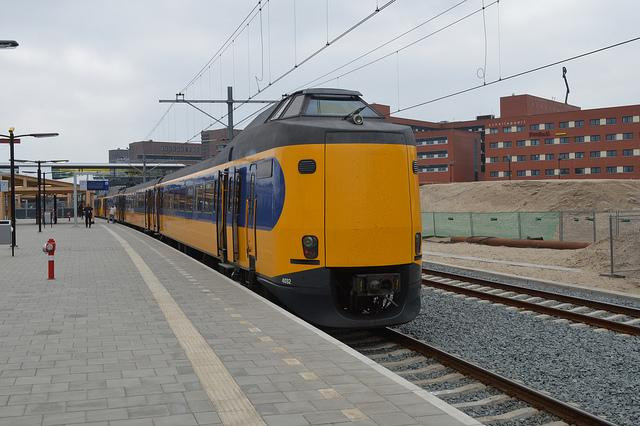What substance can be obtained from the red object? Please explain your reasoning. water. The red object is a fire hydrant. 